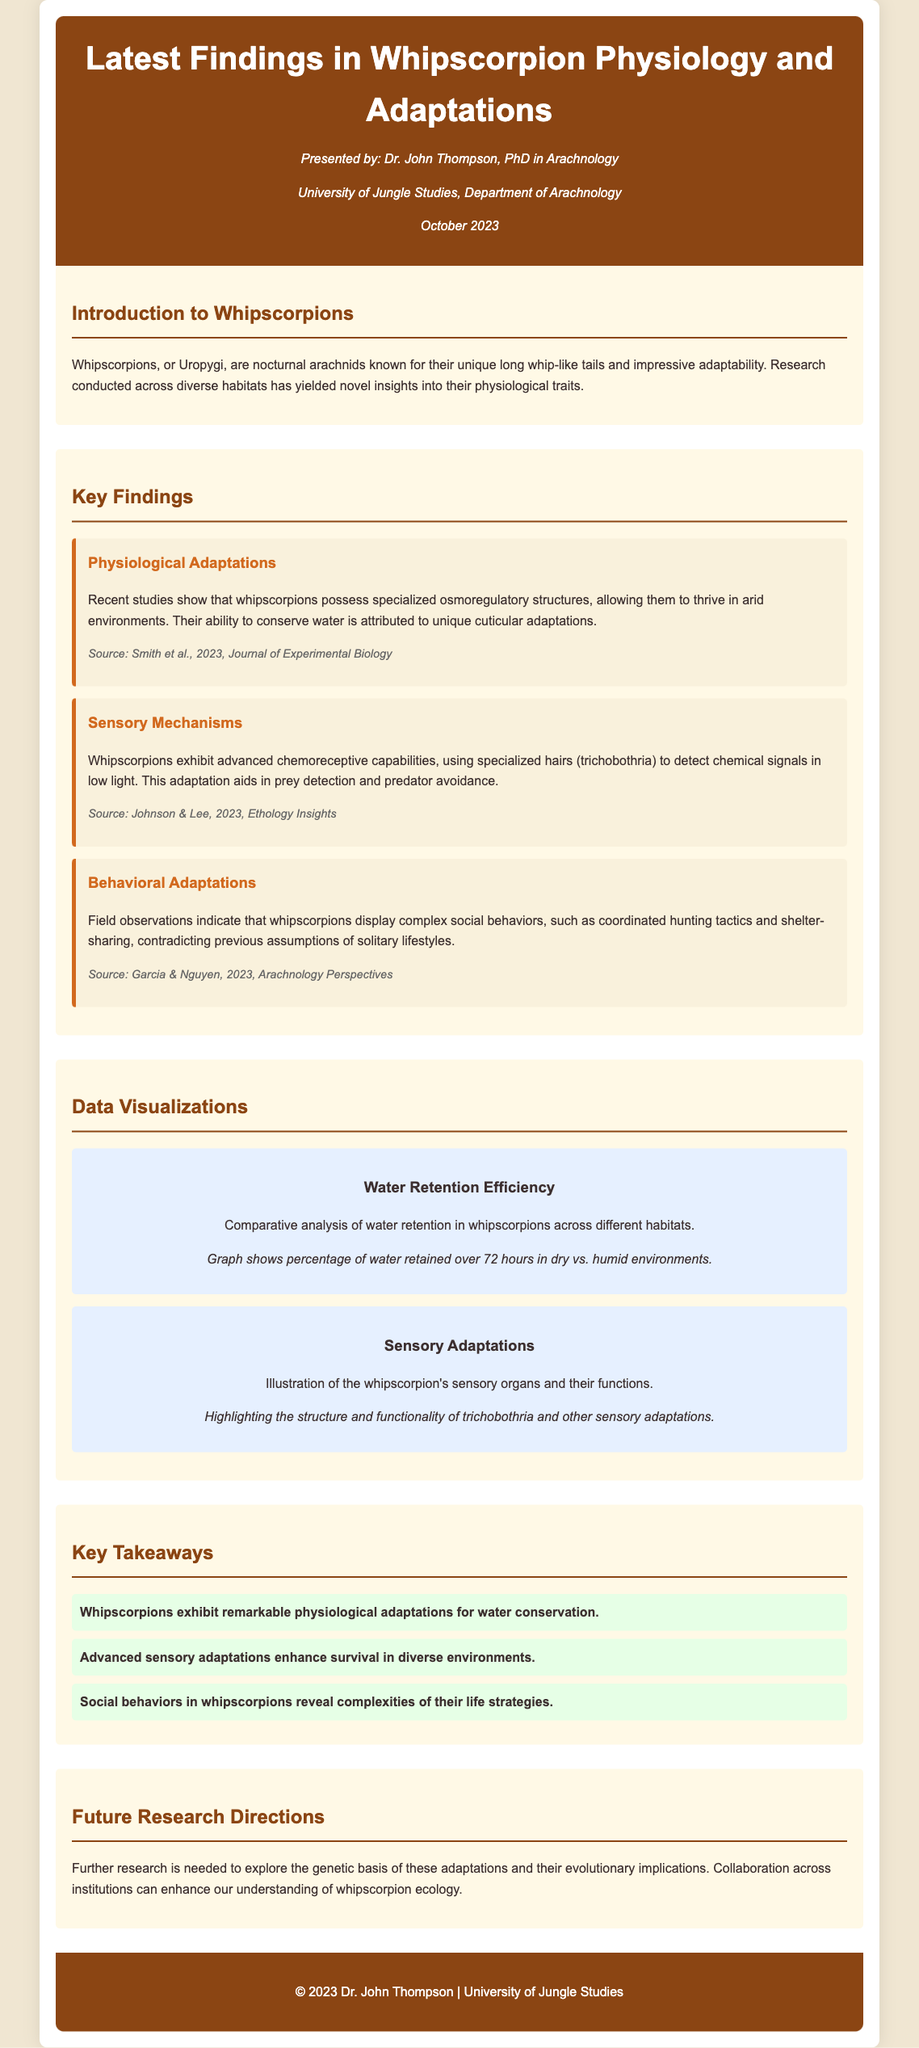What is the title of the presentation? The title is found in the header section of the document, highlighting the main focus of the presentation.
Answer: Latest Findings in Whipscorpion Physiology and Adaptations Who presented the findings? The presenter's information is included near the title, indicating who delivered the presentation.
Answer: Dr. John Thompson What is one physiological adaptation of whipscorpions? This information can be retrieved from the key findings section that discusses whipscorpion traits.
Answer: Specialized osmoregulatory structures What sensory mechanism do whipscorpions use? The document specifically states the type of sensory structure that aids in their detection abilities.
Answer: Chemoreceptive capabilities What percentage of water retention is displayed in the visualization? This question requires knowledge of the specifics of the data visualization mentioned in the document.
Answer: Not explicitly provided What behavioral trait challenges previous assumptions about whipscorpions? The document addresses specific observations that contradict earlier understandings of whipscorpion behavior.
Answer: Complex social behaviors Name a source of the findings presented in the catalog. The document lists specific studies, and their authors serve as reference points for the findings.
Answer: Smith et al., 2023 What are the implications for future research? The last section discusses directions for further studies that can be taken after the findings.
Answer: Genetic basis of adaptations 